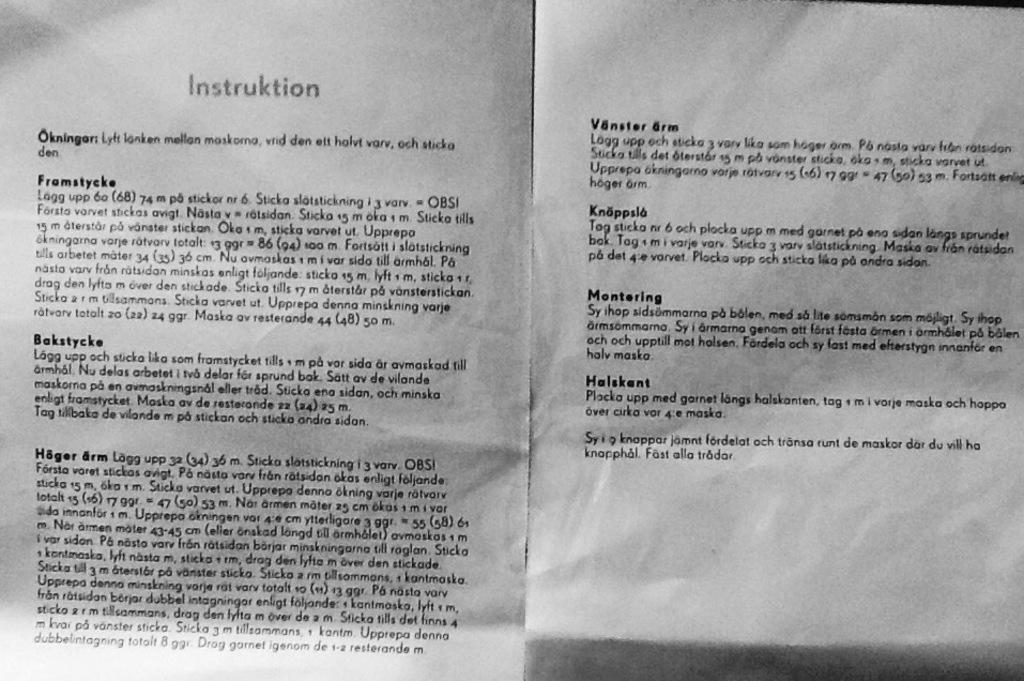<image>
Create a compact narrative representing the image presented. papers next to one another with one of them titled 'instruktion' 